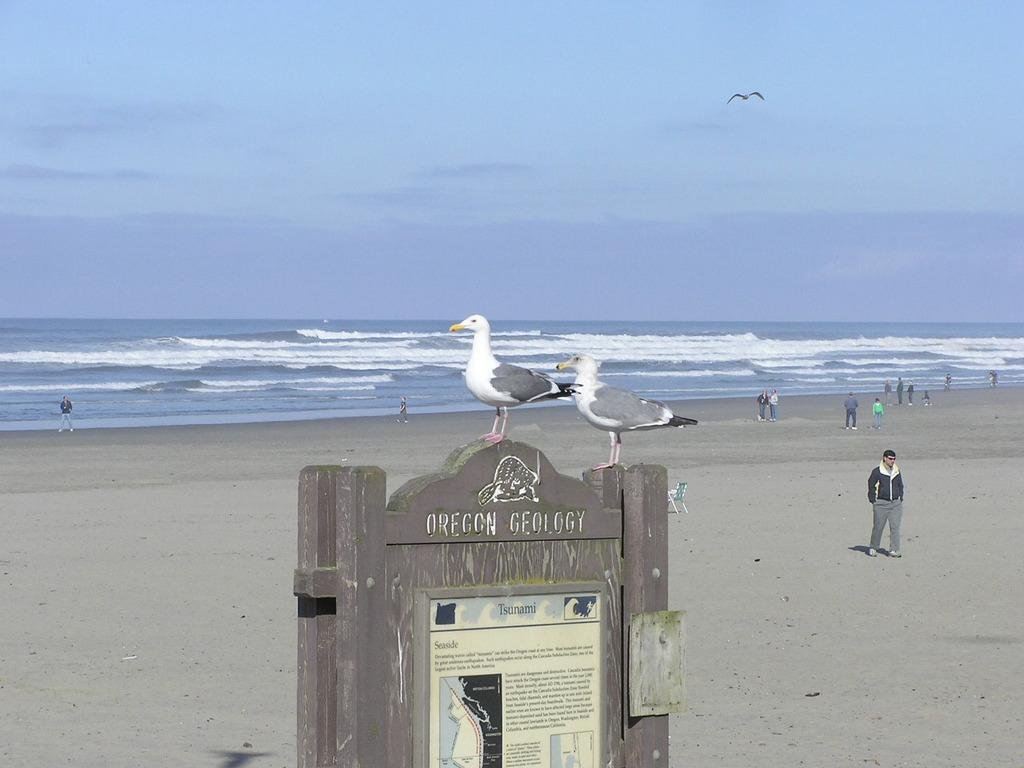What animals are on the sign board in the image? There are two birds on a sign board in the image. What can be seen on the ground near the ocean? There are people on the sea shore in the image. What large body of water is visible in the image? There is an ocean visible in the image. What is the bird in the sky doing? A bird is flying in the sky in the image. What part of the natural environment is visible in the image? The sky is visible in the image. Can you tell me how much snow is on the beach in the image? There is no snow present in the image; it features a sea shore and an ocean. What type of discussion is happening between the birds on the sign board? There is no discussion happening between the birds on the sign board, as birds do not engage in discussions. 